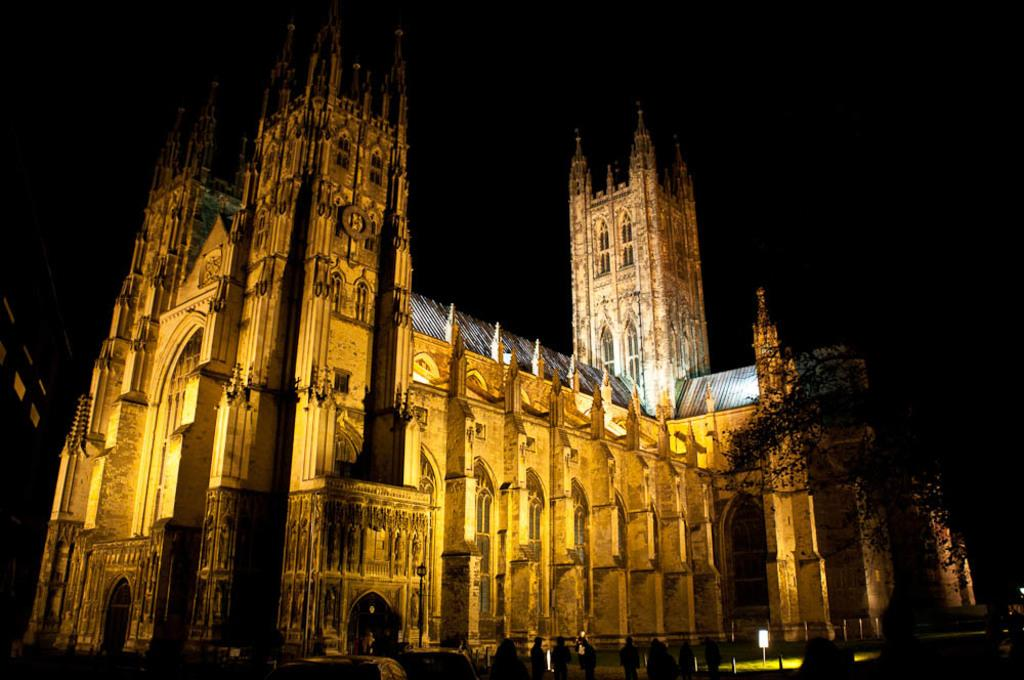What type of structure is present in the image? There is a building in the image. What feature can be seen on the building? The building has windows. Who or what else is in the image? There are people and trees in the image. What object can be seen in the image? There is a board in the image. What is the color of the background in the image? The background of the image is black. How many drawers are visible in the image? There are no drawers present in the image. What emotion are the people in the image expressing? The image does not show the emotions of the people, so it cannot be determined from the image. 